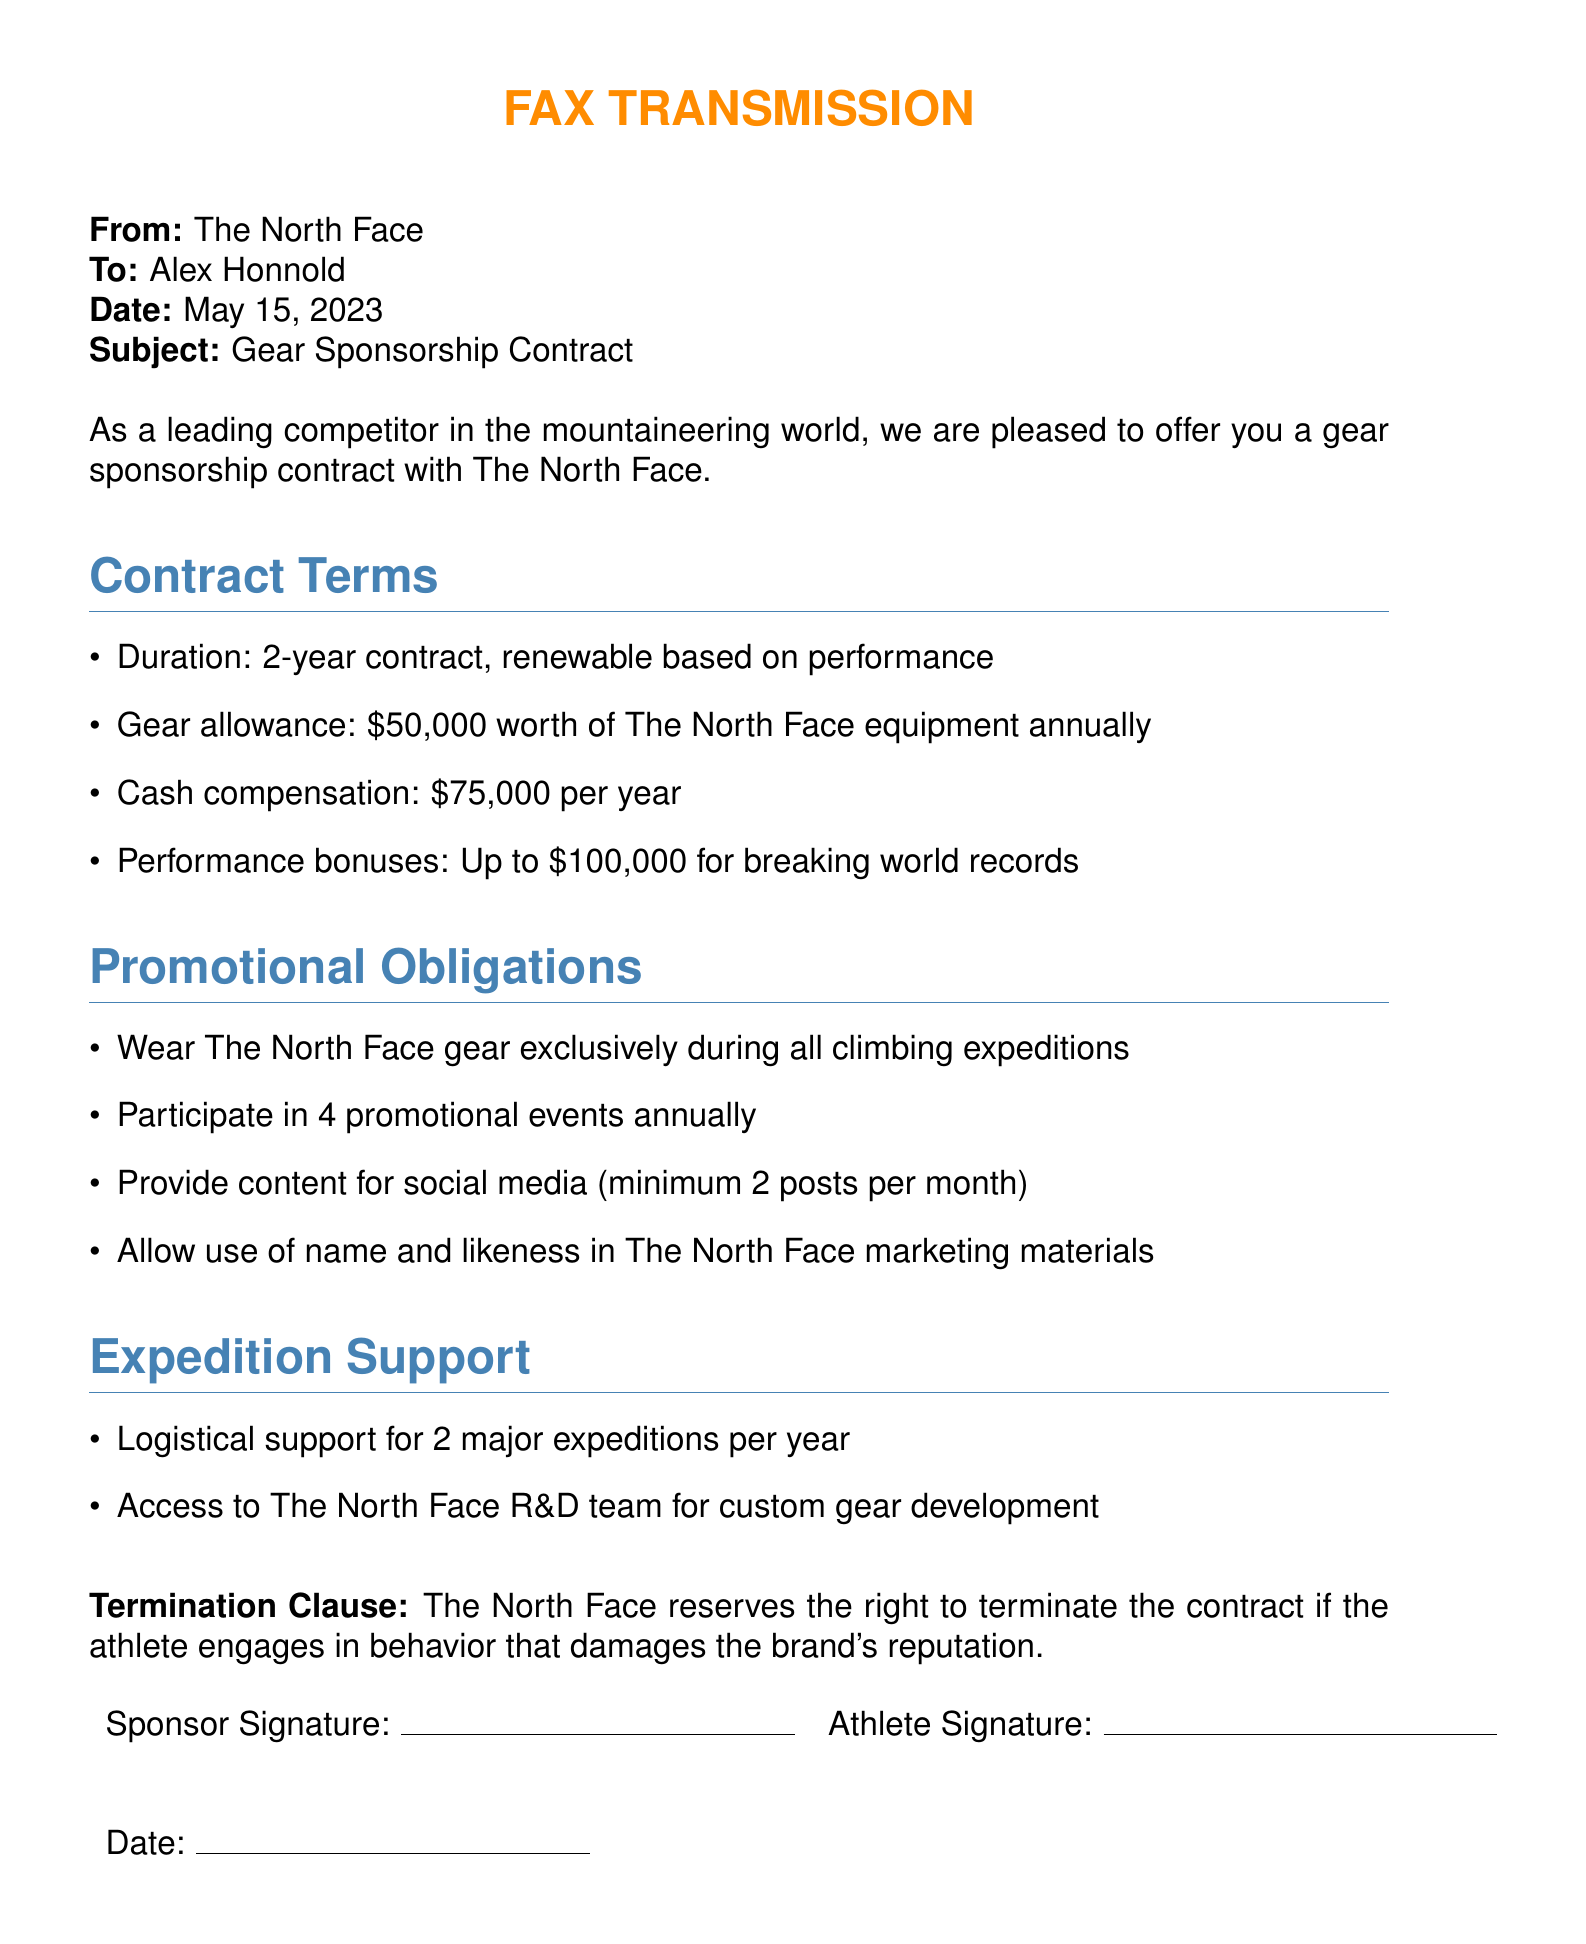What is the duration of the contract? The duration of the contract is specified as 2 years.
Answer: 2-year How much is the annual gear allowance? The contract outlines that the gear allowance is worth $50,000 annually.
Answer: $50,000 What is the cash compensation per year? The document states the cash compensation is $75,000 per year.
Answer: $75,000 How many promotional events must be participated in annually? The contract requires participation in 4 promotional events each year.
Answer: 4 What is the maximum performance bonus for breaking world records? The maximum performance bonus detailed in the contract is up to $100,000.
Answer: $100,000 What type of support is provided for expeditions? The contract specifies logistical support for 2 major expeditions per year.
Answer: Logistical support for 2 major expeditions How often must social media content be provided? It specifies a minimum of 2 posts per month for social media content.
Answer: 2 posts per month What behavior can lead to contract termination? The contract may be terminated if the athlete engages in behavior that damages the brand's reputation.
Answer: Damaging the brand's reputation What is the name of the sponsoring company? The document identifies The North Face as the sponsoring company.
Answer: The North Face 